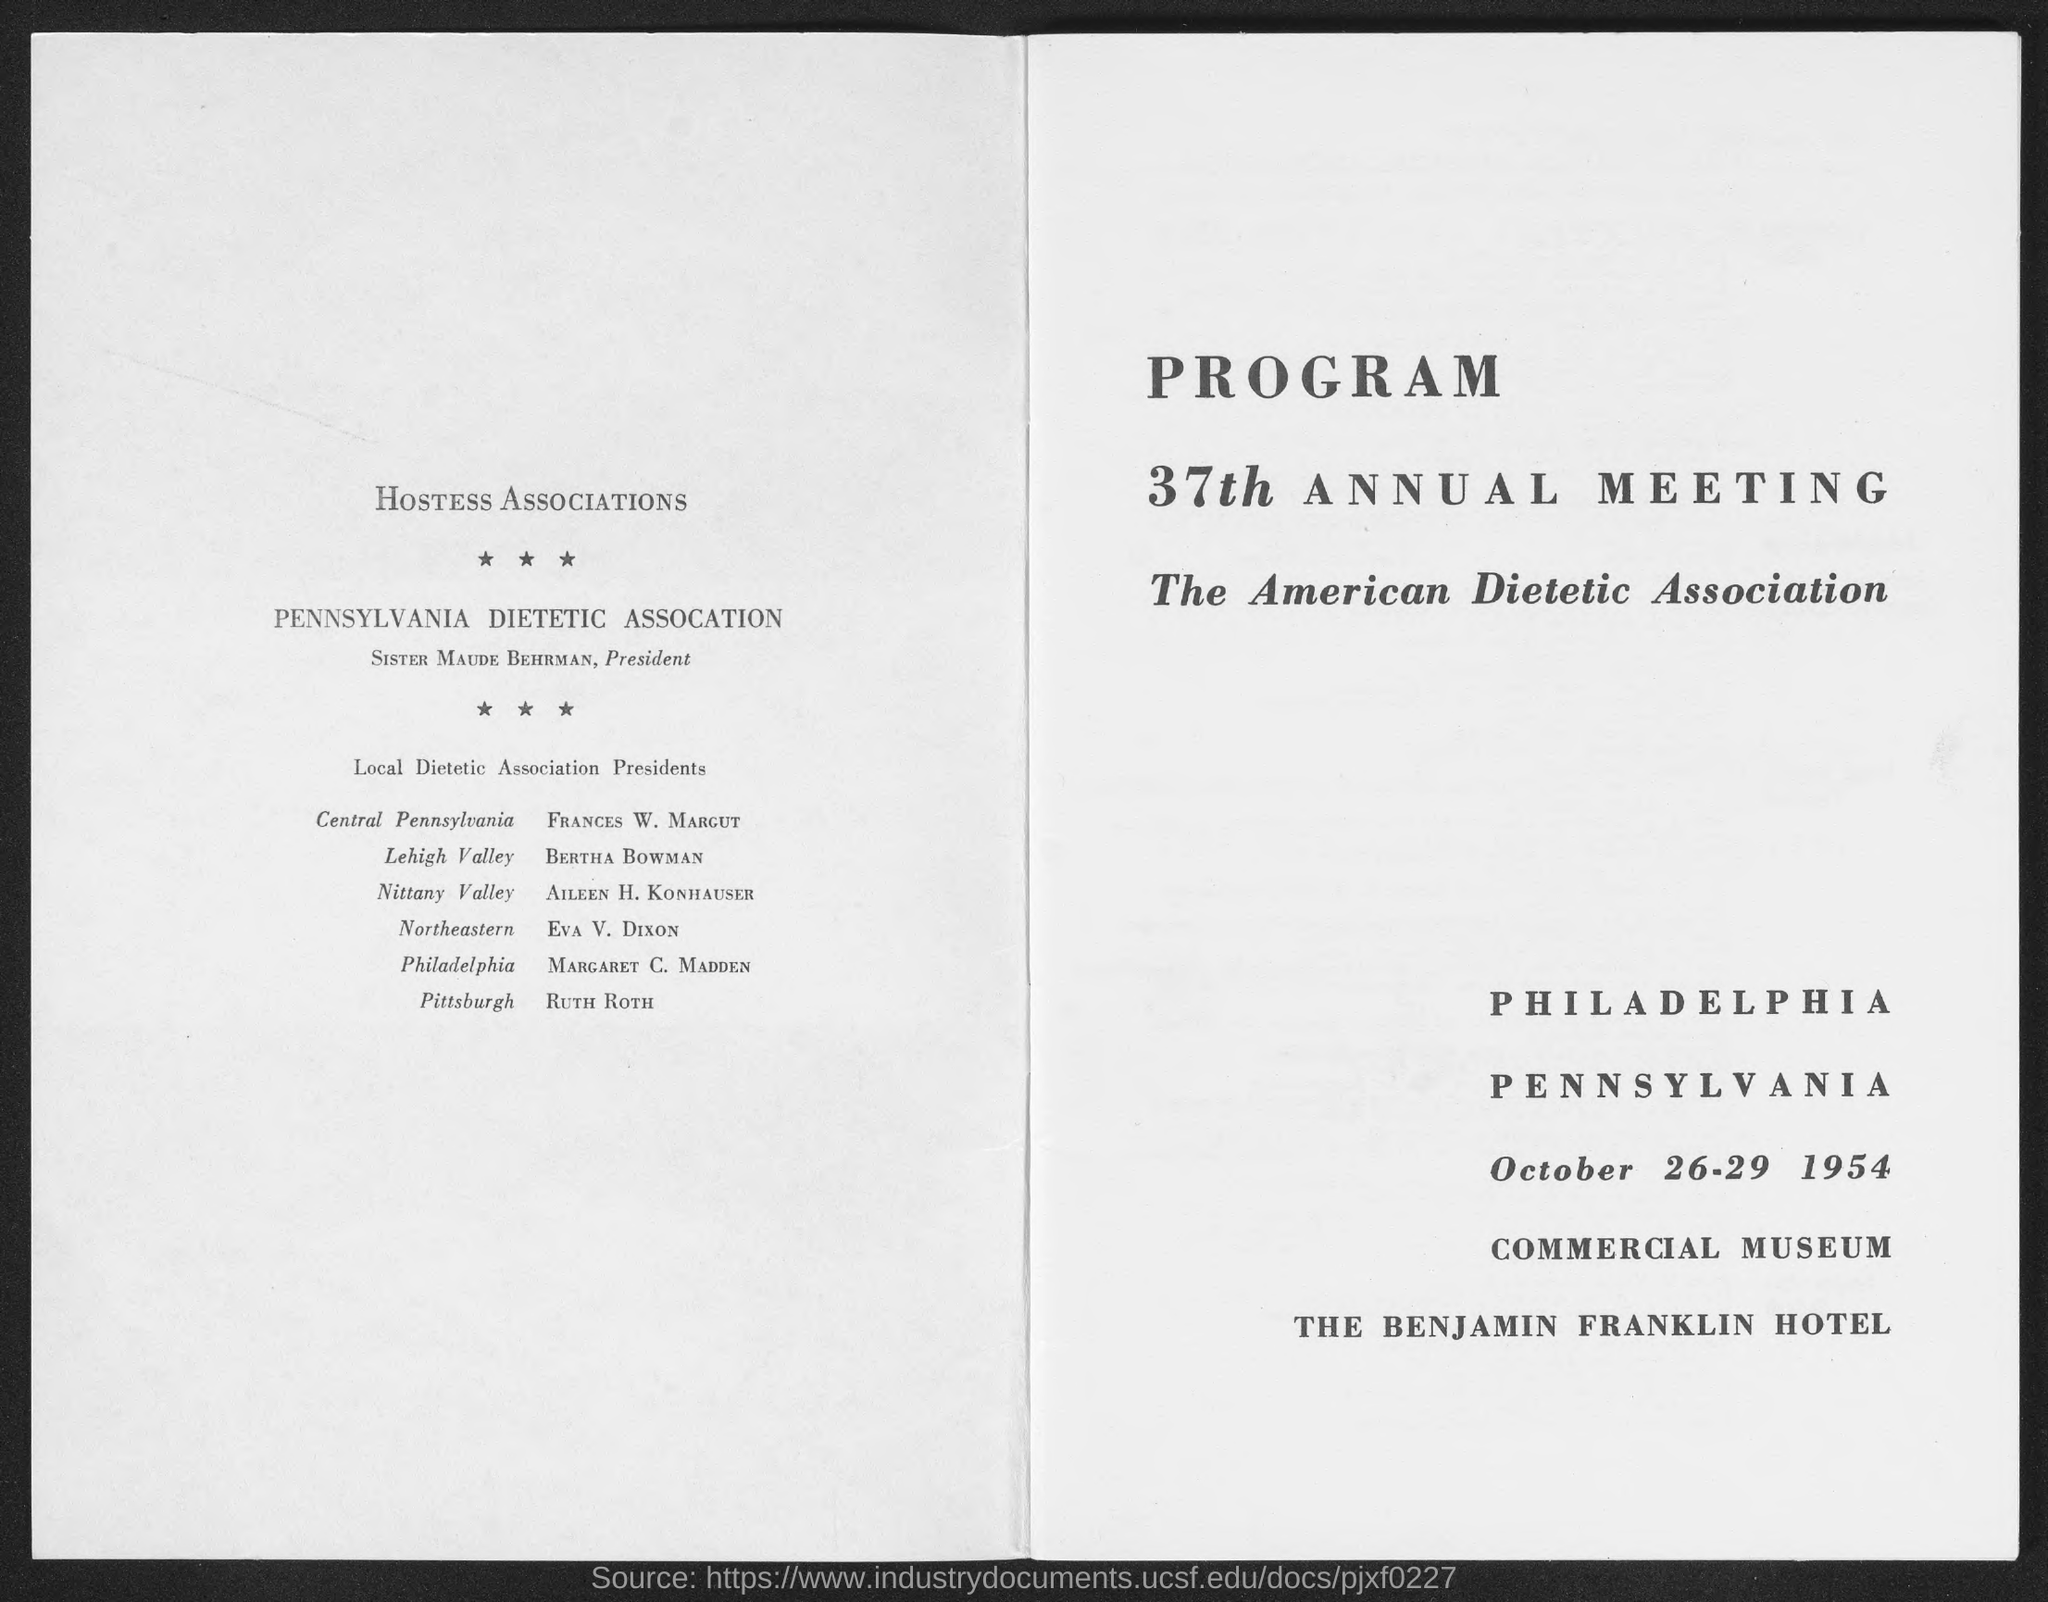When is the 37th Annual Meeting of The American Dietetic Association held?
Ensure brevity in your answer.  October 26-29 1954. Who is the President of Pennsylvania Dietetic Association?
Provide a short and direct response. Sister Maude Behrman. 